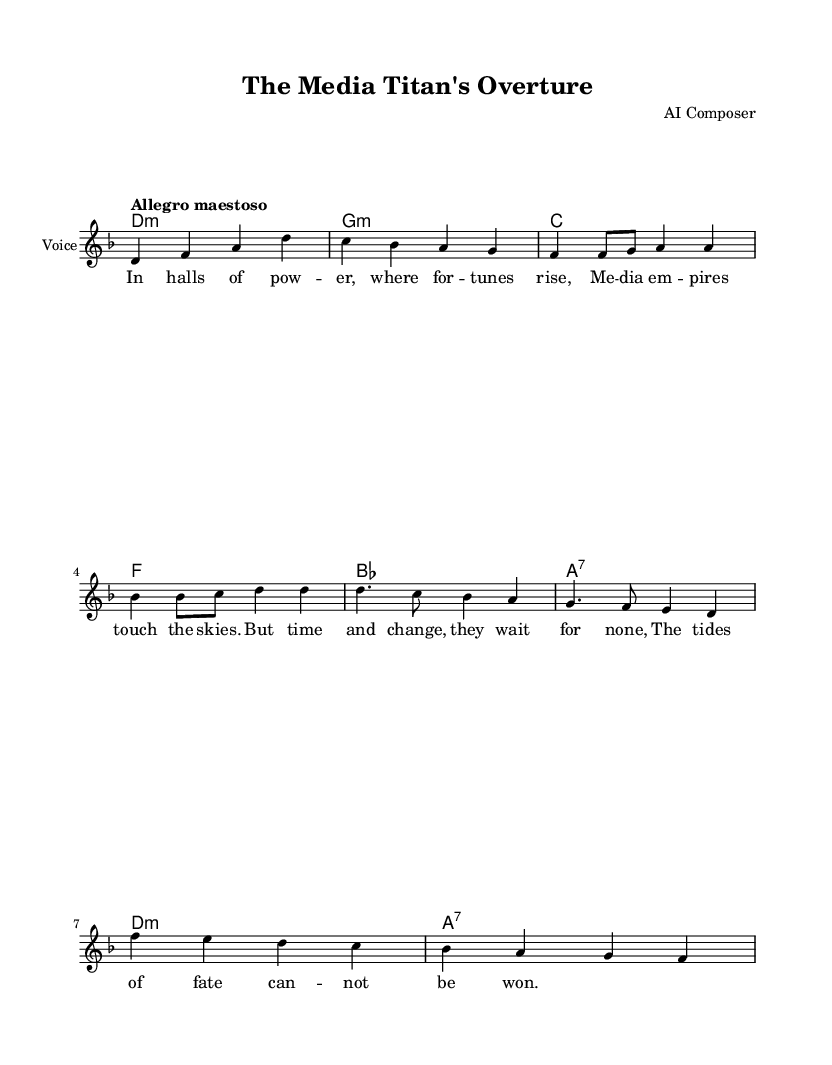What is the key signature of this music? The key signature is indicated at the beginning of the staff, noting two flats, which corresponds to the key of D minor.
Answer: D minor What is the time signature of this music? The time signature is placed at the beginning of the score, displaying a "4/4" which signifies four beats per measure.
Answer: 4/4 What is the tempo marking for this piece? The tempo marking is shown in the score following the time signature, indicating "Allegro maestoso," suggesting a lively and majestic pace.
Answer: Allegro maestoso How many measures are in the Verse section? The Verse section consists of a total of 4 measures, as can be counted in the melody section.
Answer: 4 measures What is the main theme of the chorus? The chorus lyrics reveal a thematic concern about the inevitability of time and change, hence the main theme revolves around fate and transformation.
Answer: Fate and transformation How many voices are indicated in the score? The score features one vocal line labeled as "lead," indicating a single voice arrangement, with the harmonies accompanying it.
Answer: One What instrumental accompaniment is utilized in this opera piece? The score features chord names indicating harmonic support, primarily constructed with typical accompaniment chords for operatic works, suggesting piano or orchestral accompaniment.
Answer: Chordal accompaniment 